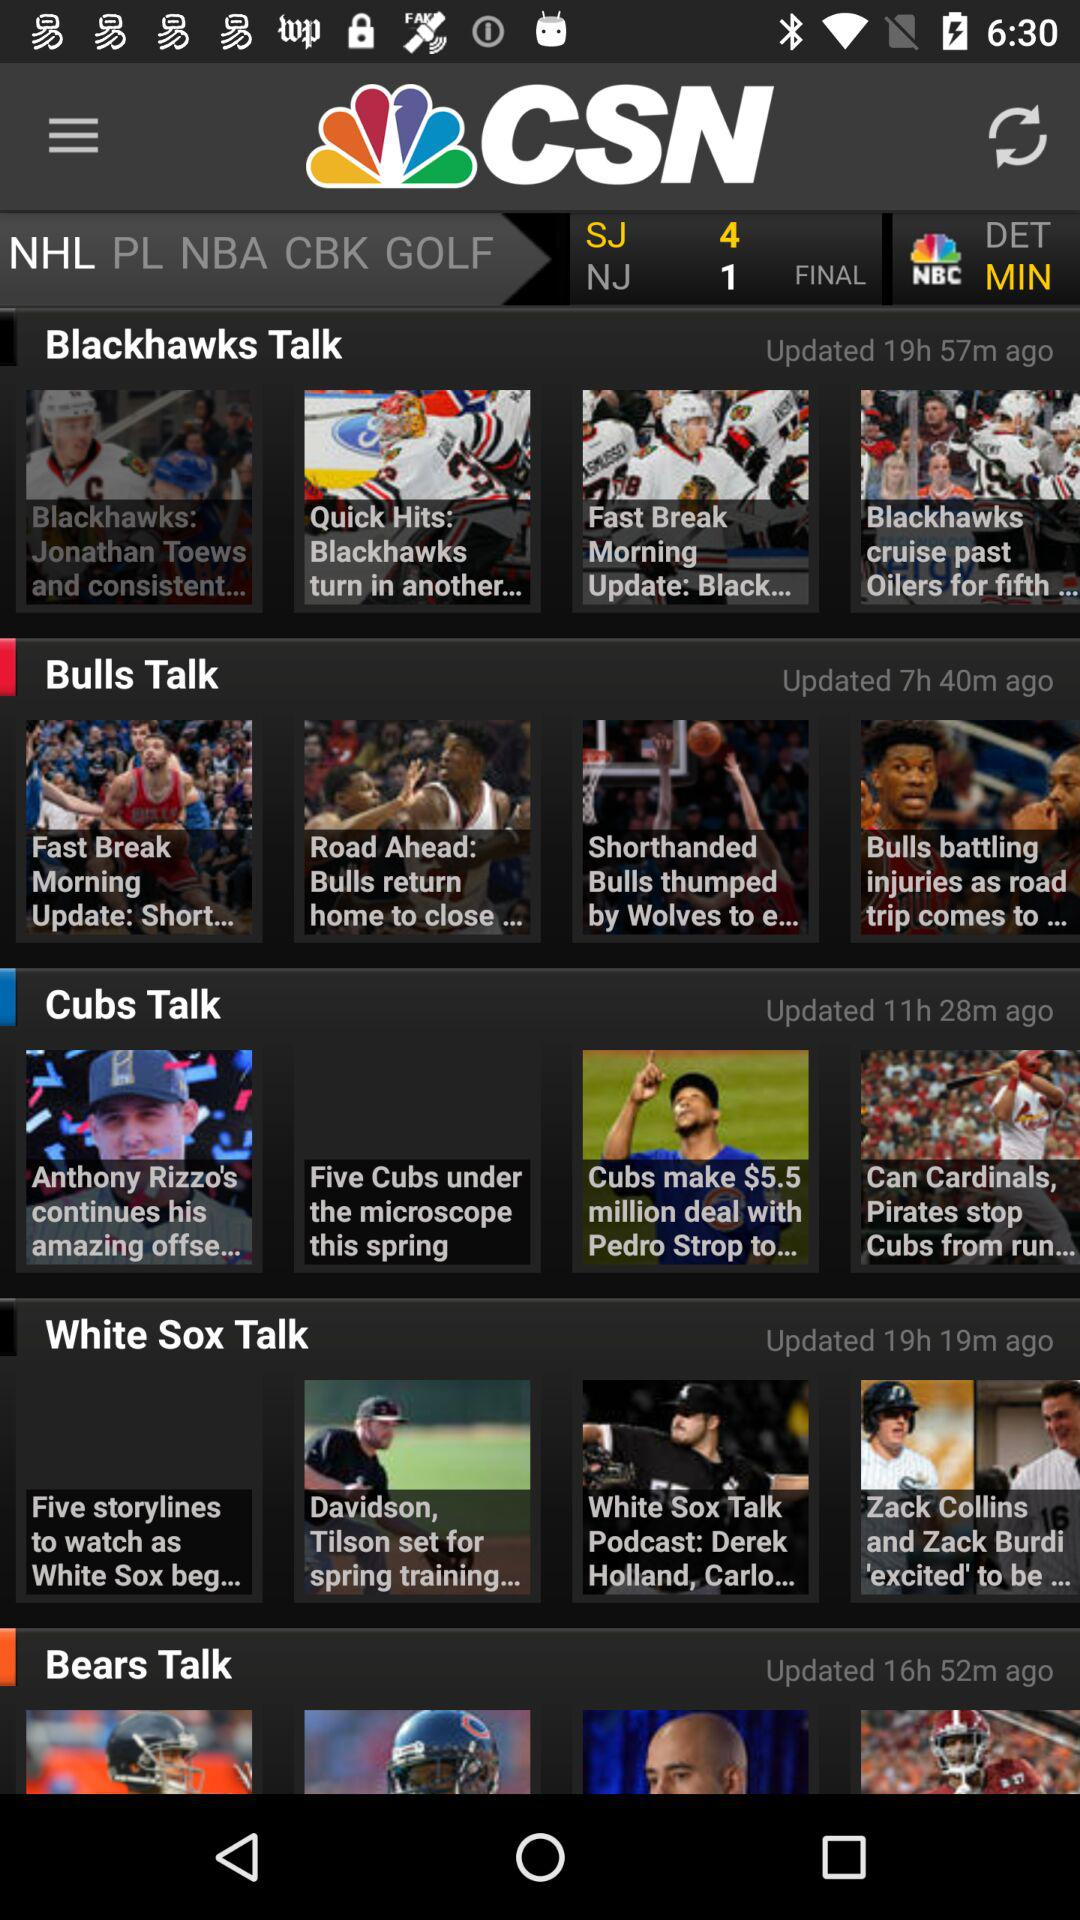When were the articles under "Bulls Talk" updated? The articles were updated 7 hours and 40 minutes ago. 